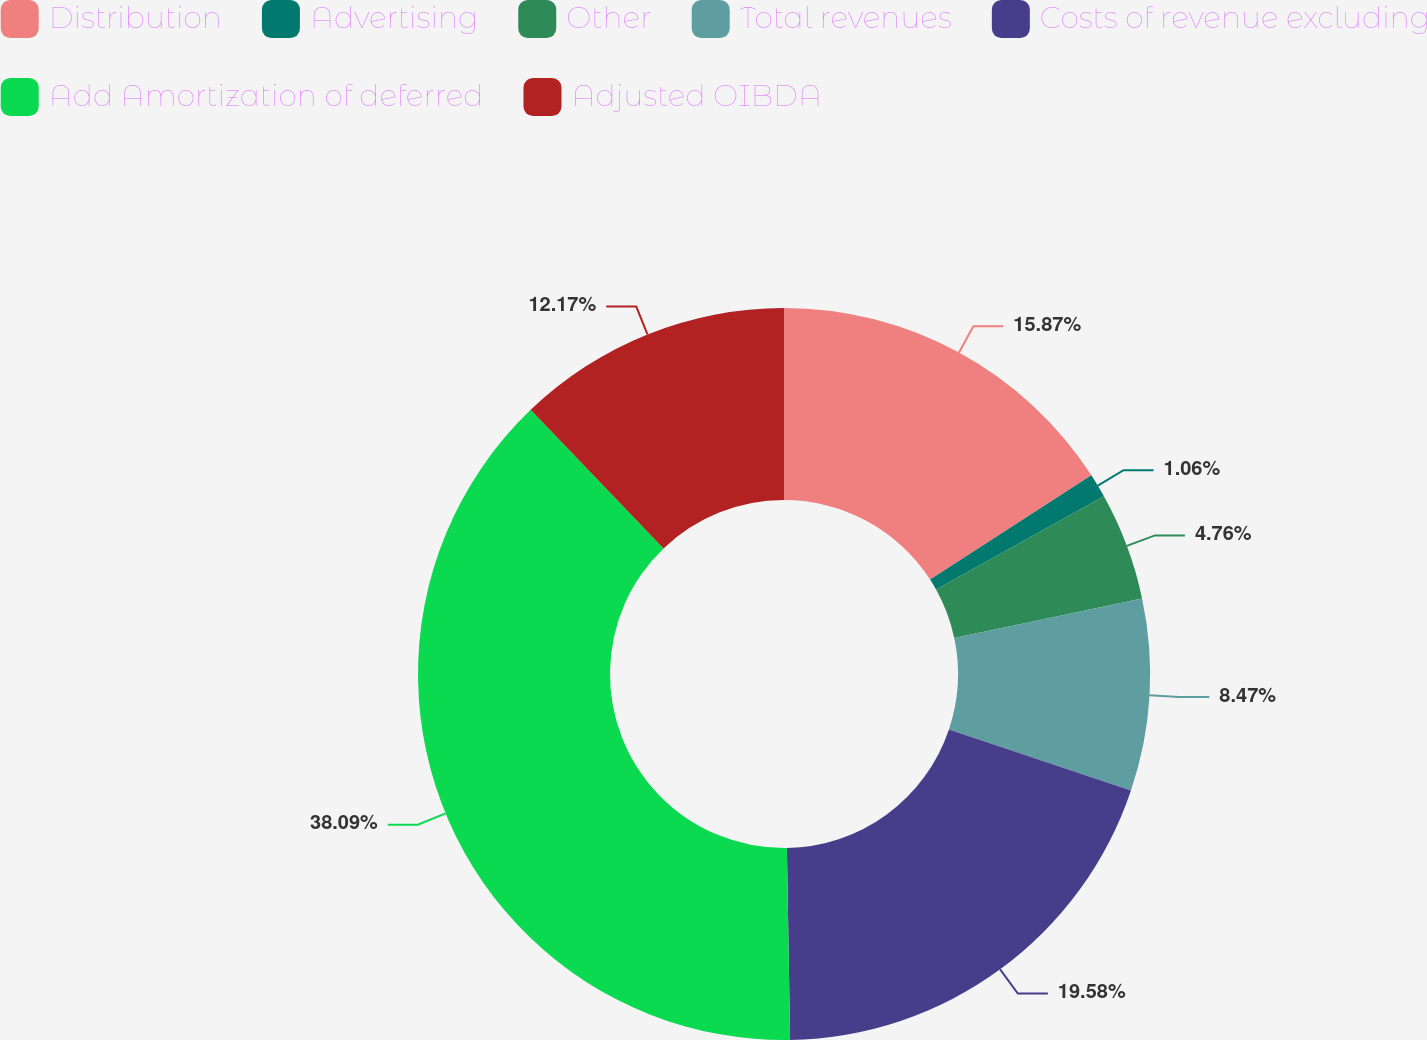Convert chart. <chart><loc_0><loc_0><loc_500><loc_500><pie_chart><fcel>Distribution<fcel>Advertising<fcel>Other<fcel>Total revenues<fcel>Costs of revenue excluding<fcel>Add Amortization of deferred<fcel>Adjusted OIBDA<nl><fcel>15.87%<fcel>1.06%<fcel>4.76%<fcel>8.47%<fcel>19.58%<fcel>38.1%<fcel>12.17%<nl></chart> 